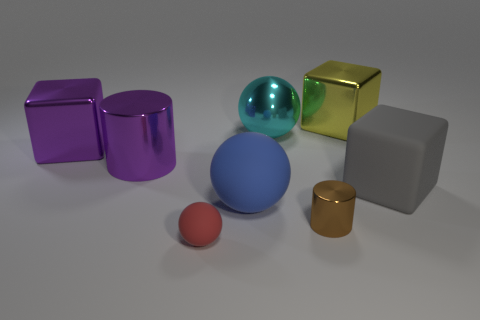What material is the large thing that is the same color as the big metal cylinder?
Offer a very short reply. Metal. How many things are big purple cubes or brown metal spheres?
Ensure brevity in your answer.  1. Are there any big objects of the same color as the large metal cylinder?
Provide a succinct answer. Yes. There is a small brown metal object that is behind the small red object; how many cubes are on the left side of it?
Provide a succinct answer. 1. Is the number of large brown metallic balls greater than the number of big gray blocks?
Your answer should be very brief. No. Do the brown thing and the large cyan sphere have the same material?
Provide a succinct answer. Yes. Is the number of large shiny balls right of the shiny sphere the same as the number of tiny purple things?
Provide a short and direct response. Yes. What number of yellow blocks are made of the same material as the big cylinder?
Make the answer very short. 1. Are there fewer tiny green metallic spheres than large gray rubber objects?
Your response must be concise. Yes. Does the large thing in front of the gray matte cube have the same color as the tiny matte object?
Your response must be concise. No. 